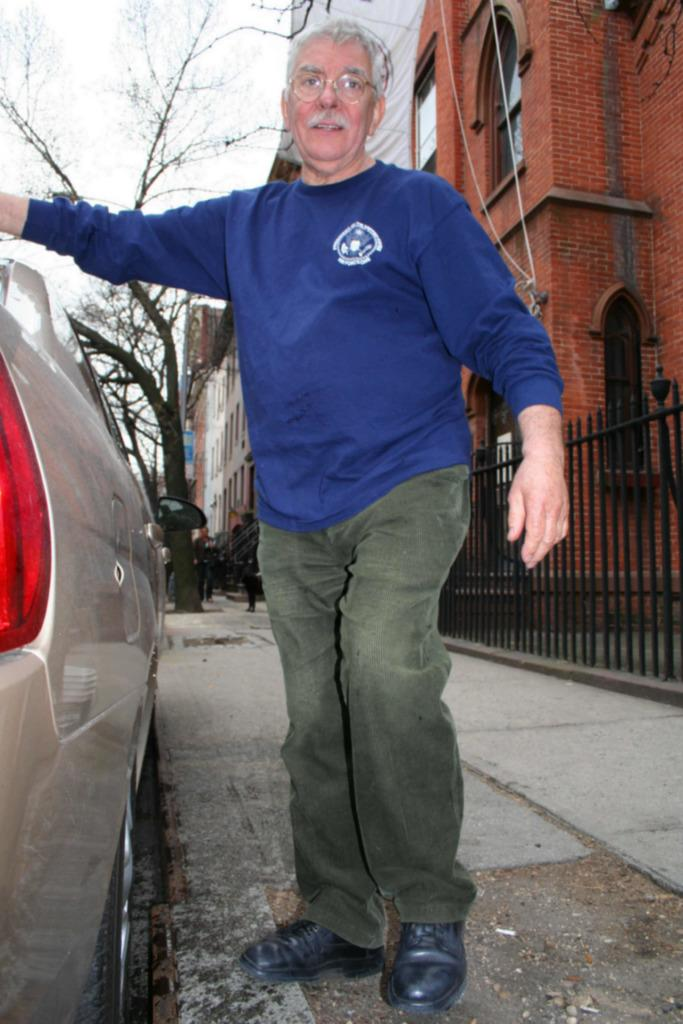Who is the main subject in the image? There is a man in the middle of the image. What is the man wearing in the image? The man is wearing spectacles. What can be seen beside the man in the image? There is a car beside the man. What is visible in the background of the image? There are buildings and trees in the background of the image. How does the man increase the speed of the foot in the image? There is no foot present in the image, so the concept of increasing its speed is not applicable. 